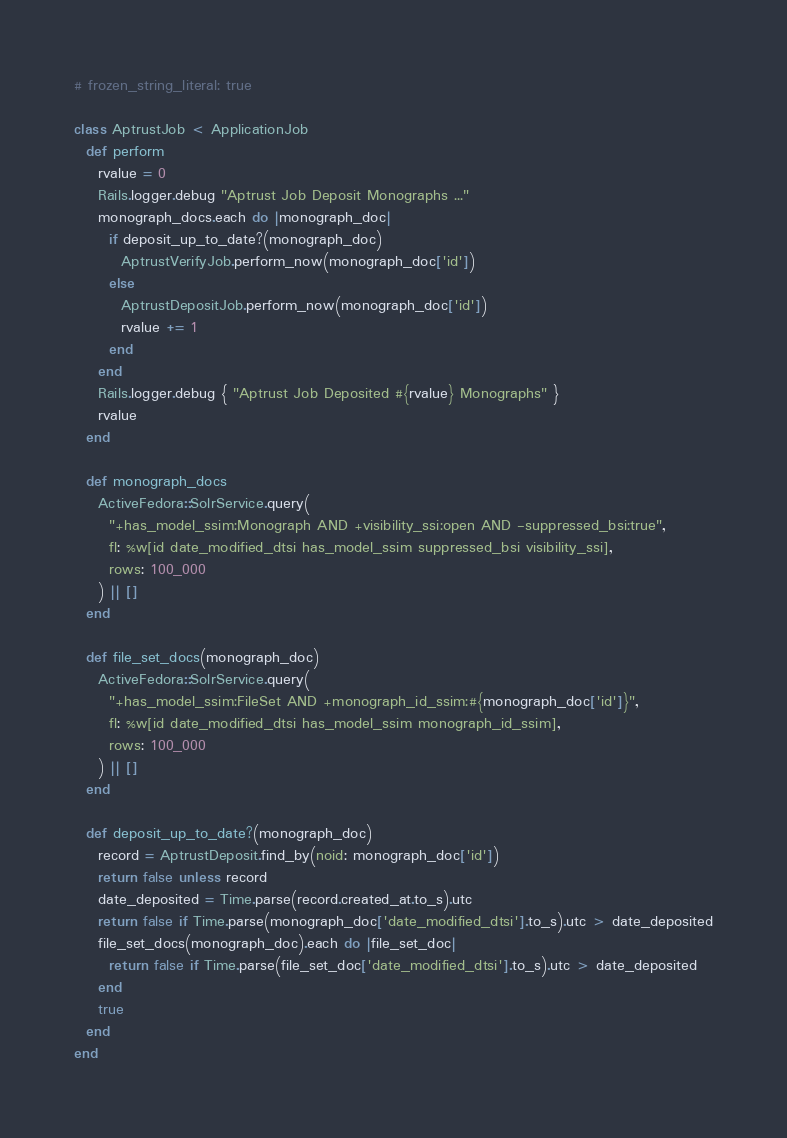Convert code to text. <code><loc_0><loc_0><loc_500><loc_500><_Ruby_># frozen_string_literal: true

class AptrustJob < ApplicationJob
  def perform
    rvalue = 0
    Rails.logger.debug "Aptrust Job Deposit Monographs ..."
    monograph_docs.each do |monograph_doc|
      if deposit_up_to_date?(monograph_doc)
        AptrustVerifyJob.perform_now(monograph_doc['id'])
      else
        AptrustDepositJob.perform_now(monograph_doc['id'])
        rvalue += 1
      end
    end
    Rails.logger.debug { "Aptrust Job Deposited #{rvalue} Monographs" }
    rvalue
  end

  def monograph_docs
    ActiveFedora::SolrService.query(
      "+has_model_ssim:Monograph AND +visibility_ssi:open AND -suppressed_bsi:true",
      fl: %w[id date_modified_dtsi has_model_ssim suppressed_bsi visibility_ssi],
      rows: 100_000
    ) || []
  end

  def file_set_docs(monograph_doc)
    ActiveFedora::SolrService.query(
      "+has_model_ssim:FileSet AND +monograph_id_ssim:#{monograph_doc['id']}",
      fl: %w[id date_modified_dtsi has_model_ssim monograph_id_ssim],
      rows: 100_000
    ) || []
  end

  def deposit_up_to_date?(monograph_doc)
    record = AptrustDeposit.find_by(noid: monograph_doc['id'])
    return false unless record
    date_deposited = Time.parse(record.created_at.to_s).utc
    return false if Time.parse(monograph_doc['date_modified_dtsi'].to_s).utc > date_deposited
    file_set_docs(monograph_doc).each do |file_set_doc|
      return false if Time.parse(file_set_doc['date_modified_dtsi'].to_s).utc > date_deposited
    end
    true
  end
end
</code> 